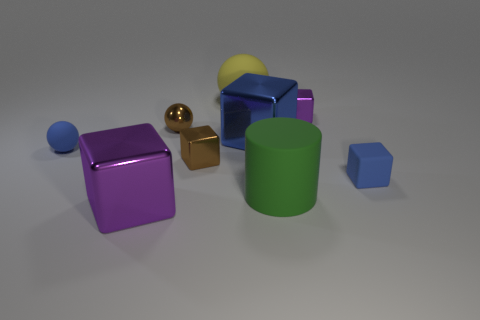What number of matte things are both right of the big purple shiny thing and in front of the yellow ball?
Keep it short and to the point. 2. Is there anything else that is the same shape as the green thing?
Your answer should be very brief. No. Is the color of the big rubber ball the same as the large matte object right of the large sphere?
Your answer should be compact. No. There is a purple object on the right side of the brown sphere; what shape is it?
Your response must be concise. Cube. How many other things are the same material as the blue ball?
Offer a terse response. 3. What is the material of the tiny purple cube?
Ensure brevity in your answer.  Metal. What number of big things are either purple shiny cubes or blue matte cylinders?
Your answer should be very brief. 1. How many rubber balls are in front of the big green rubber thing?
Your answer should be compact. 0. Is there a metal thing of the same color as the tiny rubber sphere?
Ensure brevity in your answer.  Yes. There is a purple metallic thing that is the same size as the blue shiny block; what is its shape?
Your answer should be very brief. Cube. 